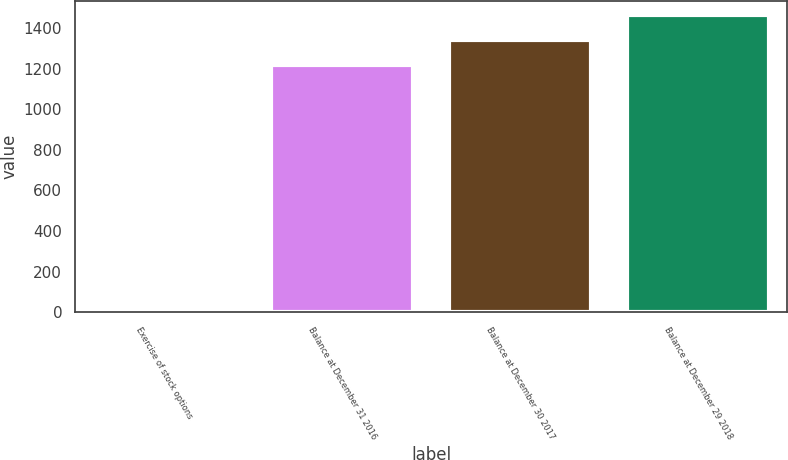<chart> <loc_0><loc_0><loc_500><loc_500><bar_chart><fcel>Exercise of stock options<fcel>Balance at December 31 2016<fcel>Balance at December 30 2017<fcel>Balance at December 29 2018<nl><fcel>5<fcel>1219<fcel>1340.9<fcel>1462.8<nl></chart> 